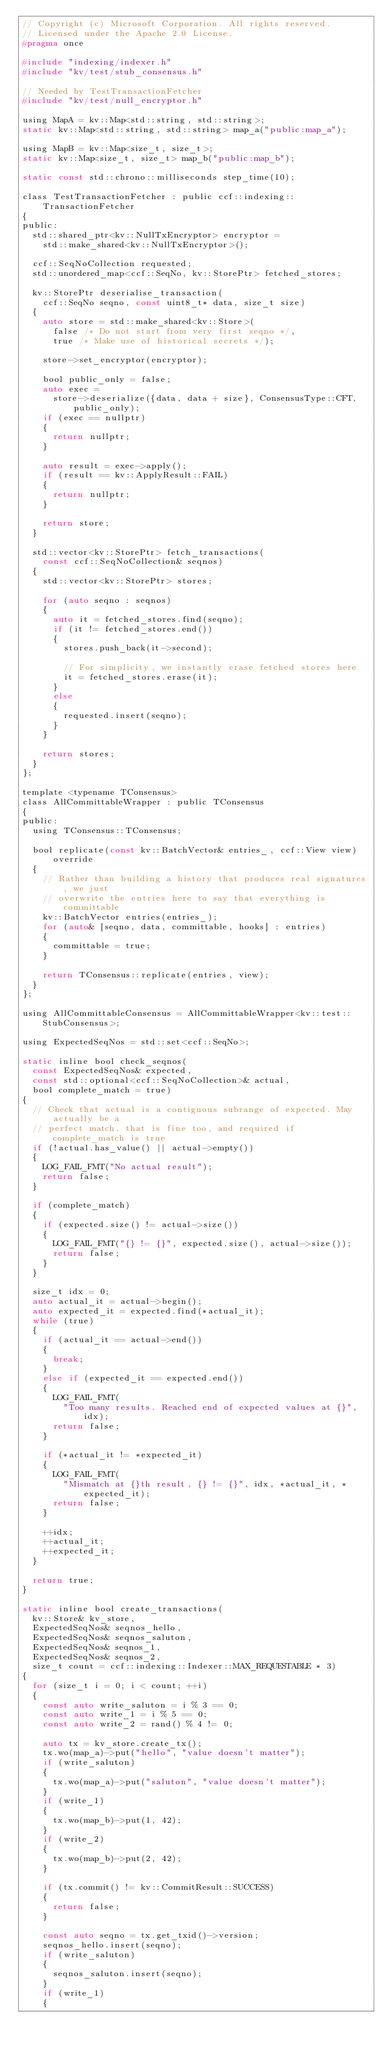Convert code to text. <code><loc_0><loc_0><loc_500><loc_500><_C_>// Copyright (c) Microsoft Corporation. All rights reserved.
// Licensed under the Apache 2.0 License.
#pragma once

#include "indexing/indexer.h"
#include "kv/test/stub_consensus.h"

// Needed by TestTransactionFetcher
#include "kv/test/null_encryptor.h"

using MapA = kv::Map<std::string, std::string>;
static kv::Map<std::string, std::string> map_a("public:map_a");

using MapB = kv::Map<size_t, size_t>;
static kv::Map<size_t, size_t> map_b("public:map_b");

static const std::chrono::milliseconds step_time(10);

class TestTransactionFetcher : public ccf::indexing::TransactionFetcher
{
public:
  std::shared_ptr<kv::NullTxEncryptor> encryptor =
    std::make_shared<kv::NullTxEncryptor>();

  ccf::SeqNoCollection requested;
  std::unordered_map<ccf::SeqNo, kv::StorePtr> fetched_stores;

  kv::StorePtr deserialise_transaction(
    ccf::SeqNo seqno, const uint8_t* data, size_t size)
  {
    auto store = std::make_shared<kv::Store>(
      false /* Do not start from very first seqno */,
      true /* Make use of historical secrets */);

    store->set_encryptor(encryptor);

    bool public_only = false;
    auto exec =
      store->deserialize({data, data + size}, ConsensusType::CFT, public_only);
    if (exec == nullptr)
    {
      return nullptr;
    }

    auto result = exec->apply();
    if (result == kv::ApplyResult::FAIL)
    {
      return nullptr;
    }

    return store;
  }

  std::vector<kv::StorePtr> fetch_transactions(
    const ccf::SeqNoCollection& seqnos)
  {
    std::vector<kv::StorePtr> stores;

    for (auto seqno : seqnos)
    {
      auto it = fetched_stores.find(seqno);
      if (it != fetched_stores.end())
      {
        stores.push_back(it->second);

        // For simplicity, we instantly erase fetched stores here
        it = fetched_stores.erase(it);
      }
      else
      {
        requested.insert(seqno);
      }
    }

    return stores;
  }
};

template <typename TConsensus>
class AllCommittableWrapper : public TConsensus
{
public:
  using TConsensus::TConsensus;

  bool replicate(const kv::BatchVector& entries_, ccf::View view) override
  {
    // Rather than building a history that produces real signatures, we just
    // overwrite the entries here to say that everything is committable
    kv::BatchVector entries(entries_);
    for (auto& [seqno, data, committable, hooks] : entries)
    {
      committable = true;
    }

    return TConsensus::replicate(entries, view);
  }
};

using AllCommittableConsensus = AllCommittableWrapper<kv::test::StubConsensus>;

using ExpectedSeqNos = std::set<ccf::SeqNo>;

static inline bool check_seqnos(
  const ExpectedSeqNos& expected,
  const std::optional<ccf::SeqNoCollection>& actual,
  bool complete_match = true)
{
  // Check that actual is a contiguous subrange of expected. May actually be a
  // perfect match, that is fine too, and required if complete_match is true
  if (!actual.has_value() || actual->empty())
  {
    LOG_FAIL_FMT("No actual result");
    return false;
  }

  if (complete_match)
  {
    if (expected.size() != actual->size())
    {
      LOG_FAIL_FMT("{} != {}", expected.size(), actual->size());
      return false;
    }
  }

  size_t idx = 0;
  auto actual_it = actual->begin();
  auto expected_it = expected.find(*actual_it);
  while (true)
  {
    if (actual_it == actual->end())
    {
      break;
    }
    else if (expected_it == expected.end())
    {
      LOG_FAIL_FMT(
        "Too many results. Reached end of expected values at {}", idx);
      return false;
    }

    if (*actual_it != *expected_it)
    {
      LOG_FAIL_FMT(
        "Mismatch at {}th result, {} != {}", idx, *actual_it, *expected_it);
      return false;
    }

    ++idx;
    ++actual_it;
    ++expected_it;
  }

  return true;
}

static inline bool create_transactions(
  kv::Store& kv_store,
  ExpectedSeqNos& seqnos_hello,
  ExpectedSeqNos& seqnos_saluton,
  ExpectedSeqNos& seqnos_1,
  ExpectedSeqNos& seqnos_2,
  size_t count = ccf::indexing::Indexer::MAX_REQUESTABLE * 3)
{
  for (size_t i = 0; i < count; ++i)
  {
    const auto write_saluton = i % 3 == 0;
    const auto write_1 = i % 5 == 0;
    const auto write_2 = rand() % 4 != 0;

    auto tx = kv_store.create_tx();
    tx.wo(map_a)->put("hello", "value doesn't matter");
    if (write_saluton)
    {
      tx.wo(map_a)->put("saluton", "value doesn't matter");
    }
    if (write_1)
    {
      tx.wo(map_b)->put(1, 42);
    }
    if (write_2)
    {
      tx.wo(map_b)->put(2, 42);
    }

    if (tx.commit() != kv::CommitResult::SUCCESS)
    {
      return false;
    }

    const auto seqno = tx.get_txid()->version;
    seqnos_hello.insert(seqno);
    if (write_saluton)
    {
      seqnos_saluton.insert(seqno);
    }
    if (write_1)
    {</code> 